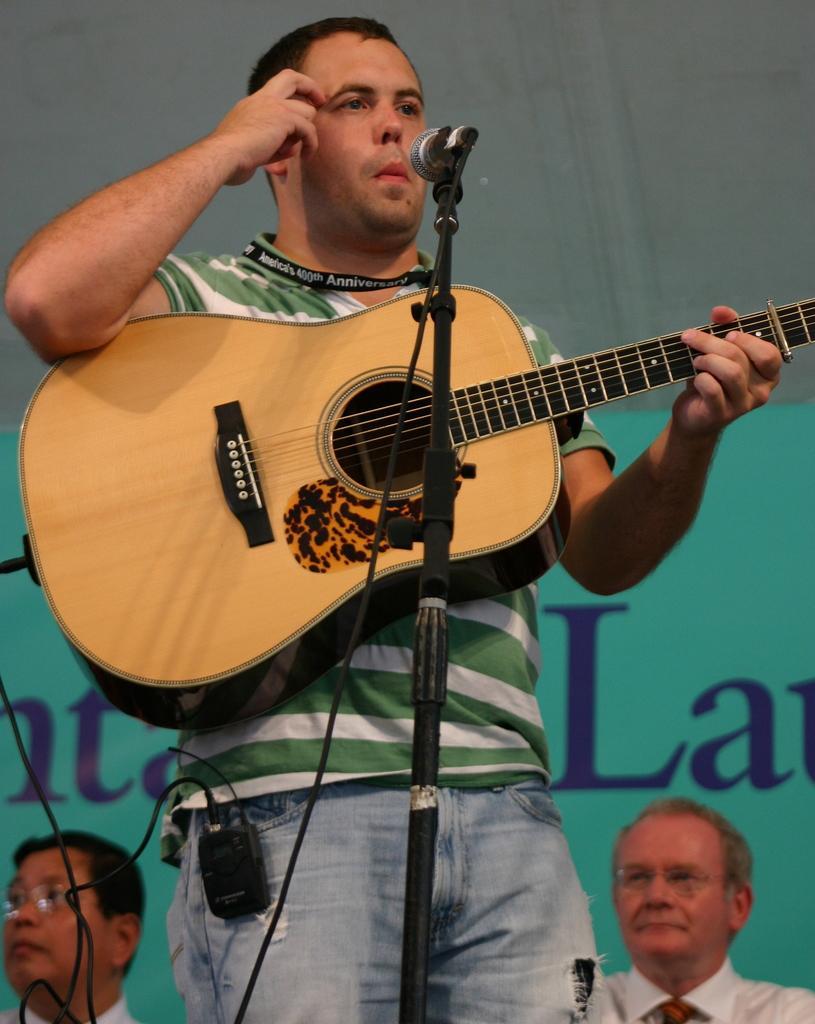Describe this image in one or two sentences. In this image, In the middle there is a man standing and holding a microphone which is in black color and holding a music instrument in yellow color, In the background there are some people sitting and there is a wall and blue color poster. 